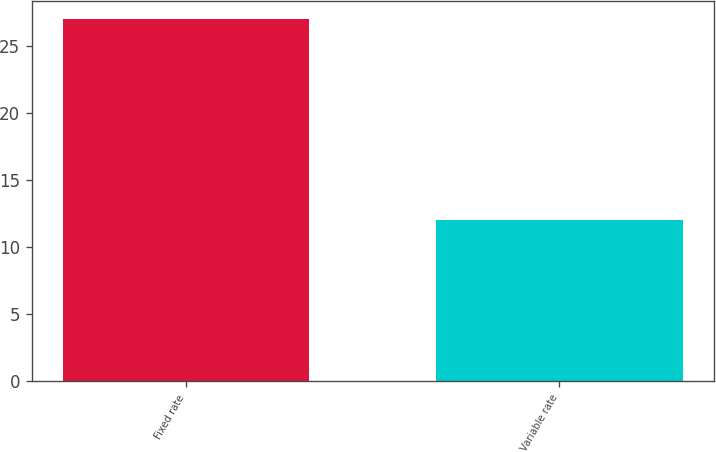Convert chart. <chart><loc_0><loc_0><loc_500><loc_500><bar_chart><fcel>Fixed rate<fcel>Variable rate<nl><fcel>27<fcel>12<nl></chart> 